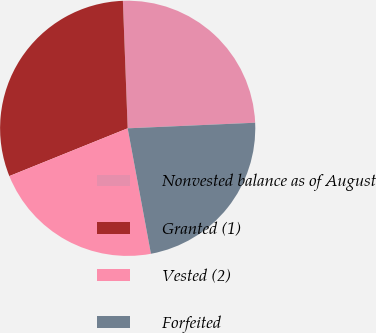Convert chart. <chart><loc_0><loc_0><loc_500><loc_500><pie_chart><fcel>Nonvested balance as of August<fcel>Granted (1)<fcel>Vested (2)<fcel>Forfeited<nl><fcel>24.9%<fcel>30.51%<fcel>21.81%<fcel>22.78%<nl></chart> 